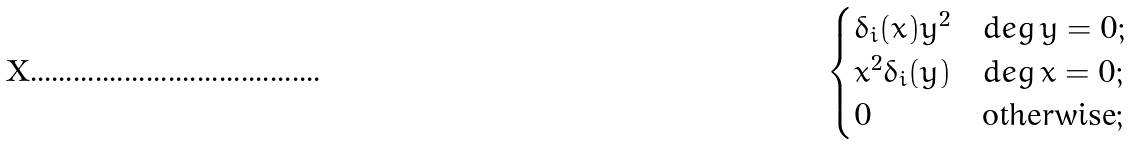<formula> <loc_0><loc_0><loc_500><loc_500>\begin{cases} \delta _ { i } ( x ) y ^ { 2 } & d e g \, y = 0 ; \\ x ^ { 2 } \delta _ { i } ( y ) & d e g \, x = 0 ; \\ 0 & \text {otherwise} ; \end{cases}</formula> 